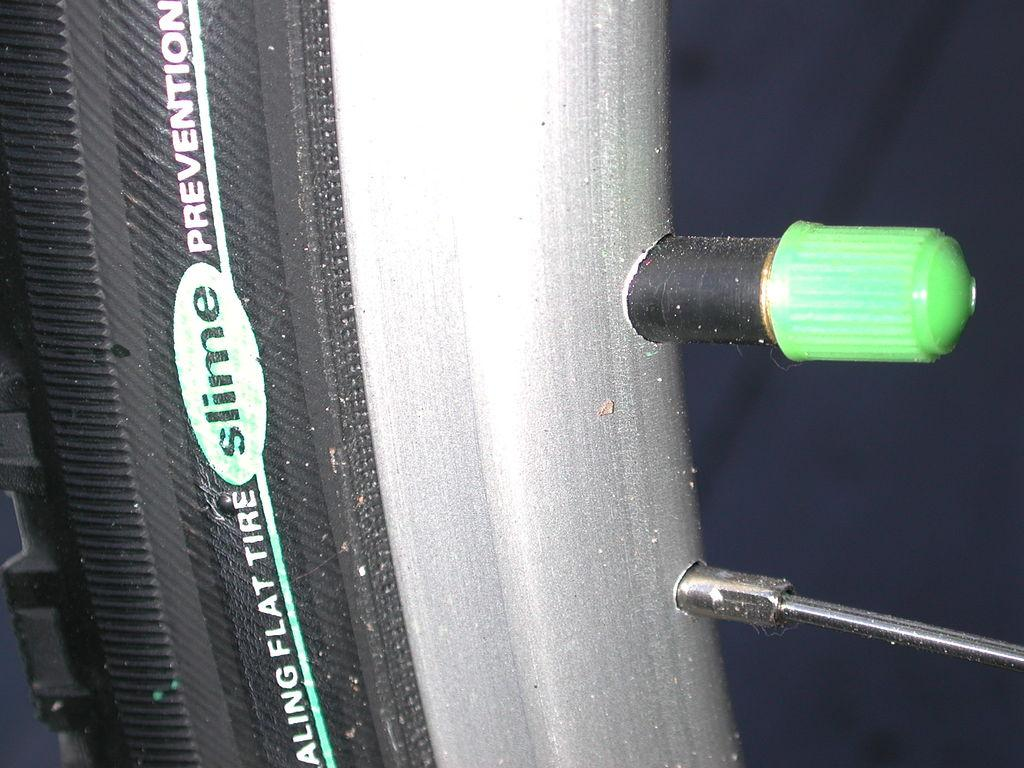<image>
Provide a brief description of the given image. A tire has the word SLIME on it in a green oval. 